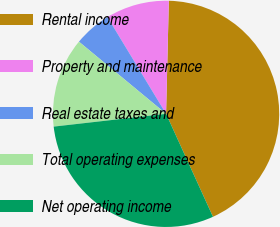Convert chart to OTSL. <chart><loc_0><loc_0><loc_500><loc_500><pie_chart><fcel>Rental income<fcel>Property and maintenance<fcel>Real estate taxes and<fcel>Total operating expenses<fcel>Net operating income<nl><fcel>42.81%<fcel>9.06%<fcel>5.32%<fcel>12.81%<fcel>30.0%<nl></chart> 